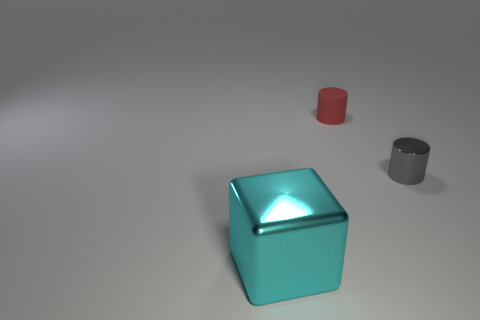There is a metallic thing that is on the right side of the metal block left of the rubber cylinder; what is its shape?
Provide a short and direct response. Cylinder. Are there any matte things that have the same size as the gray metal object?
Provide a succinct answer. Yes. Are there more objects than large cyan shiny things?
Give a very brief answer. Yes. Do the cylinder that is behind the gray metal cylinder and the object in front of the gray cylinder have the same size?
Give a very brief answer. No. What number of things are behind the big cyan object and in front of the small red thing?
Offer a terse response. 1. The other object that is the same shape as the gray shiny thing is what color?
Make the answer very short. Red. Are there fewer tiny blue rubber spheres than red cylinders?
Keep it short and to the point. Yes. There is a red object; is its size the same as the metallic object that is on the left side of the red cylinder?
Make the answer very short. No. What color is the metal thing right of the shiny thing in front of the tiny gray cylinder?
Offer a very short reply. Gray. How many objects are small cylinders that are in front of the rubber cylinder or objects that are behind the cyan metal cube?
Offer a terse response. 2. 